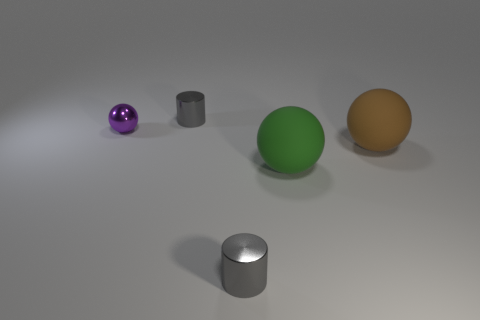What is the material of the tiny gray cylinder in front of the shiny thing behind the purple metallic thing?
Offer a terse response. Metal. Are there an equal number of tiny metal spheres that are on the right side of the big green thing and small cyan matte spheres?
Make the answer very short. Yes. What is the size of the object that is in front of the purple metallic ball and behind the green ball?
Offer a terse response. Large. The metallic object right of the gray object behind the tiny purple thing is what color?
Offer a terse response. Gray. How many blue things are small metallic things or large matte balls?
Your answer should be compact. 0. What color is the object that is both in front of the brown ball and on the left side of the green rubber ball?
Ensure brevity in your answer.  Gray. What number of big objects are either gray metal cylinders or purple shiny balls?
Provide a succinct answer. 0. The purple thing that is the same shape as the big green rubber object is what size?
Provide a succinct answer. Small. What is the shape of the brown matte object?
Ensure brevity in your answer.  Sphere. Does the large green sphere have the same material as the gray object that is behind the tiny metallic ball?
Offer a very short reply. No. 